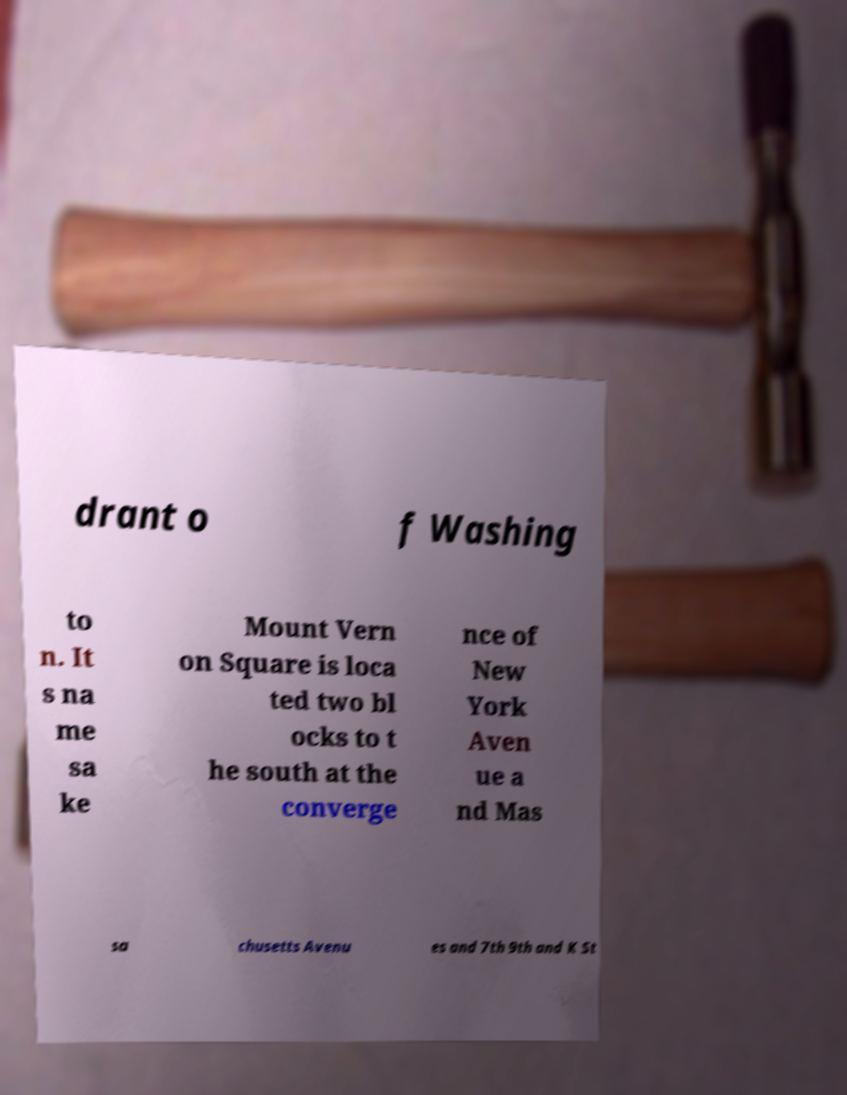What messages or text are displayed in this image? I need them in a readable, typed format. drant o f Washing to n. It s na me sa ke Mount Vern on Square is loca ted two bl ocks to t he south at the converge nce of New York Aven ue a nd Mas sa chusetts Avenu es and 7th 9th and K St 